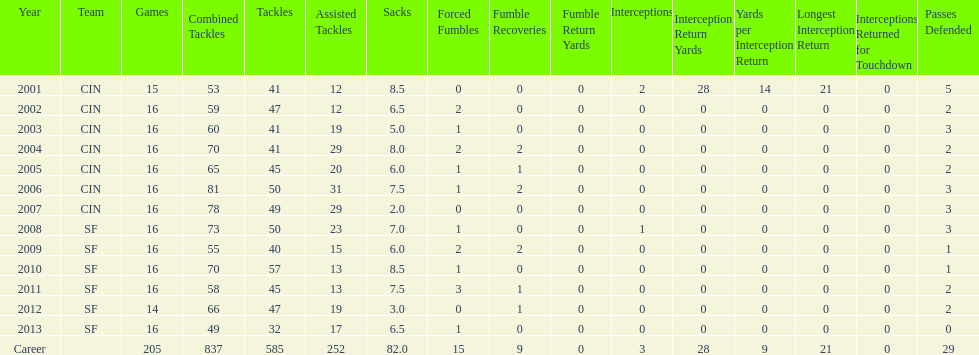What was the number of combined tackles in 2010? 70. 